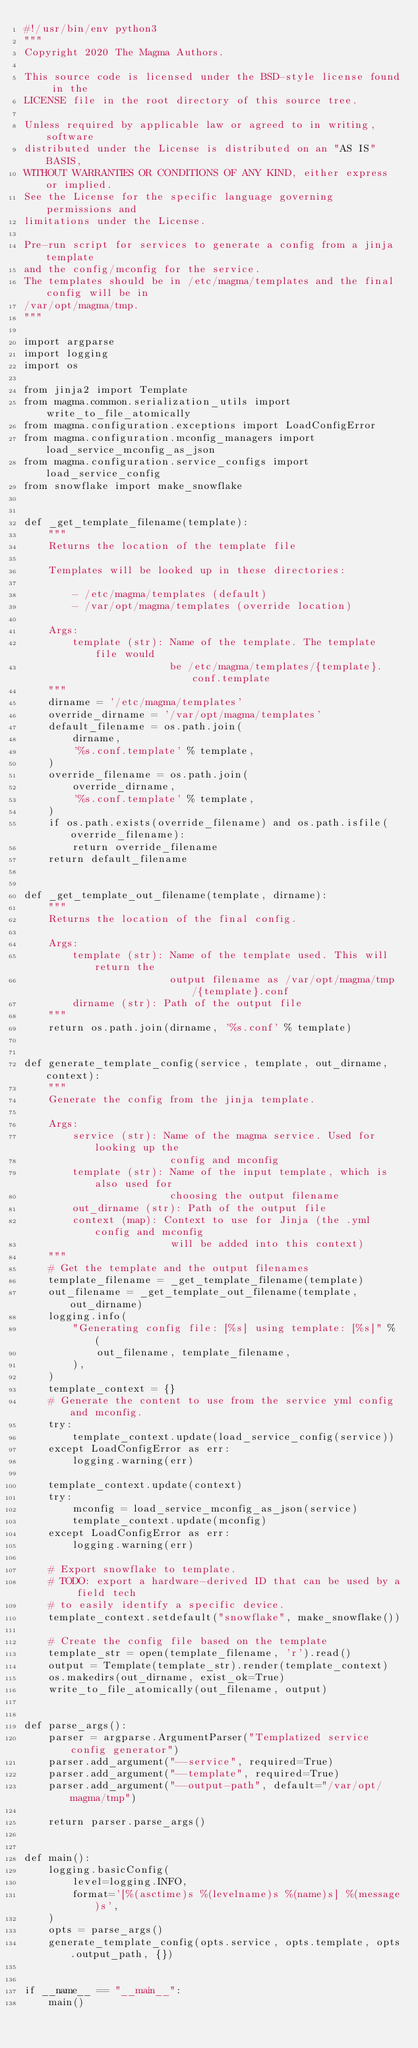Convert code to text. <code><loc_0><loc_0><loc_500><loc_500><_Python_>#!/usr/bin/env python3
"""
Copyright 2020 The Magma Authors.

This source code is licensed under the BSD-style license found in the
LICENSE file in the root directory of this source tree.

Unless required by applicable law or agreed to in writing, software
distributed under the License is distributed on an "AS IS" BASIS,
WITHOUT WARRANTIES OR CONDITIONS OF ANY KIND, either express or implied.
See the License for the specific language governing permissions and
limitations under the License.

Pre-run script for services to generate a config from a jinja template
and the config/mconfig for the service.
The templates should be in /etc/magma/templates and the final config will be in
/var/opt/magma/tmp.
"""

import argparse
import logging
import os

from jinja2 import Template
from magma.common.serialization_utils import write_to_file_atomically
from magma.configuration.exceptions import LoadConfigError
from magma.configuration.mconfig_managers import load_service_mconfig_as_json
from magma.configuration.service_configs import load_service_config
from snowflake import make_snowflake


def _get_template_filename(template):
    """
    Returns the location of the template file

    Templates will be looked up in these directories:

        - /etc/magma/templates (default)
        - /var/opt/magma/templates (override location)

    Args:
        template (str): Name of the template. The template file would
                        be /etc/magma/templates/{template}.conf.template
    """
    dirname = '/etc/magma/templates'
    override_dirname = '/var/opt/magma/templates'
    default_filename = os.path.join(
        dirname,
        '%s.conf.template' % template,
    )
    override_filename = os.path.join(
        override_dirname,
        '%s.conf.template' % template,
    )
    if os.path.exists(override_filename) and os.path.isfile(override_filename):
        return override_filename
    return default_filename


def _get_template_out_filename(template, dirname):
    """
    Returns the location of the final config.

    Args:
        template (str): Name of the template used. This will return the
                        output filename as /var/opt/magma/tmp/{template}.conf
        dirname (str): Path of the output file
    """
    return os.path.join(dirname, '%s.conf' % template)


def generate_template_config(service, template, out_dirname, context):
    """
    Generate the config from the jinja template.

    Args:
        service (str): Name of the magma service. Used for looking up the
                        config and mconfig
        template (str): Name of the input template, which is also used for
                        choosing the output filename
        out_dirname (str): Path of the output file
        context (map): Context to use for Jinja (the .yml config and mconfig
                        will be added into this context)
    """
    # Get the template and the output filenames
    template_filename = _get_template_filename(template)
    out_filename = _get_template_out_filename(template, out_dirname)
    logging.info(
        "Generating config file: [%s] using template: [%s]" % (
            out_filename, template_filename,
        ),
    )
    template_context = {}
    # Generate the content to use from the service yml config and mconfig.
    try:
        template_context.update(load_service_config(service))
    except LoadConfigError as err:
        logging.warning(err)

    template_context.update(context)
    try:
        mconfig = load_service_mconfig_as_json(service)
        template_context.update(mconfig)
    except LoadConfigError as err:
        logging.warning(err)

    # Export snowflake to template.
    # TODO: export a hardware-derived ID that can be used by a field tech
    # to easily identify a specific device.
    template_context.setdefault("snowflake", make_snowflake())

    # Create the config file based on the template
    template_str = open(template_filename, 'r').read()
    output = Template(template_str).render(template_context)
    os.makedirs(out_dirname, exist_ok=True)
    write_to_file_atomically(out_filename, output)


def parse_args():
    parser = argparse.ArgumentParser("Templatized service config generator")
    parser.add_argument("--service", required=True)
    parser.add_argument("--template", required=True)
    parser.add_argument("--output-path", default="/var/opt/magma/tmp")

    return parser.parse_args()


def main():
    logging.basicConfig(
        level=logging.INFO,
        format='[%(asctime)s %(levelname)s %(name)s] %(message)s',
    )
    opts = parse_args()
    generate_template_config(opts.service, opts.template, opts.output_path, {})


if __name__ == "__main__":
    main()
</code> 